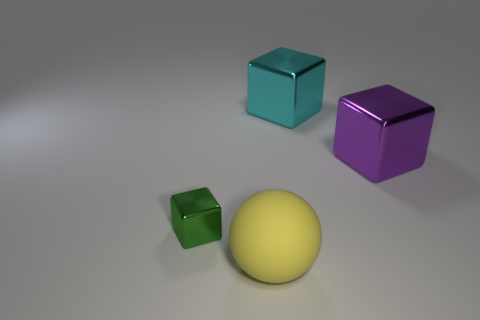Add 1 small cyan metallic things. How many objects exist? 5 Subtract all cyan blocks. How many blocks are left? 2 Add 4 tiny green metal cubes. How many tiny green metal cubes are left? 5 Add 1 yellow spheres. How many yellow spheres exist? 2 Subtract all purple blocks. How many blocks are left? 2 Subtract 0 gray balls. How many objects are left? 4 Subtract all cubes. How many objects are left? 1 Subtract 2 blocks. How many blocks are left? 1 Subtract all yellow cubes. Subtract all purple spheres. How many cubes are left? 3 Subtract all red cylinders. How many yellow cubes are left? 0 